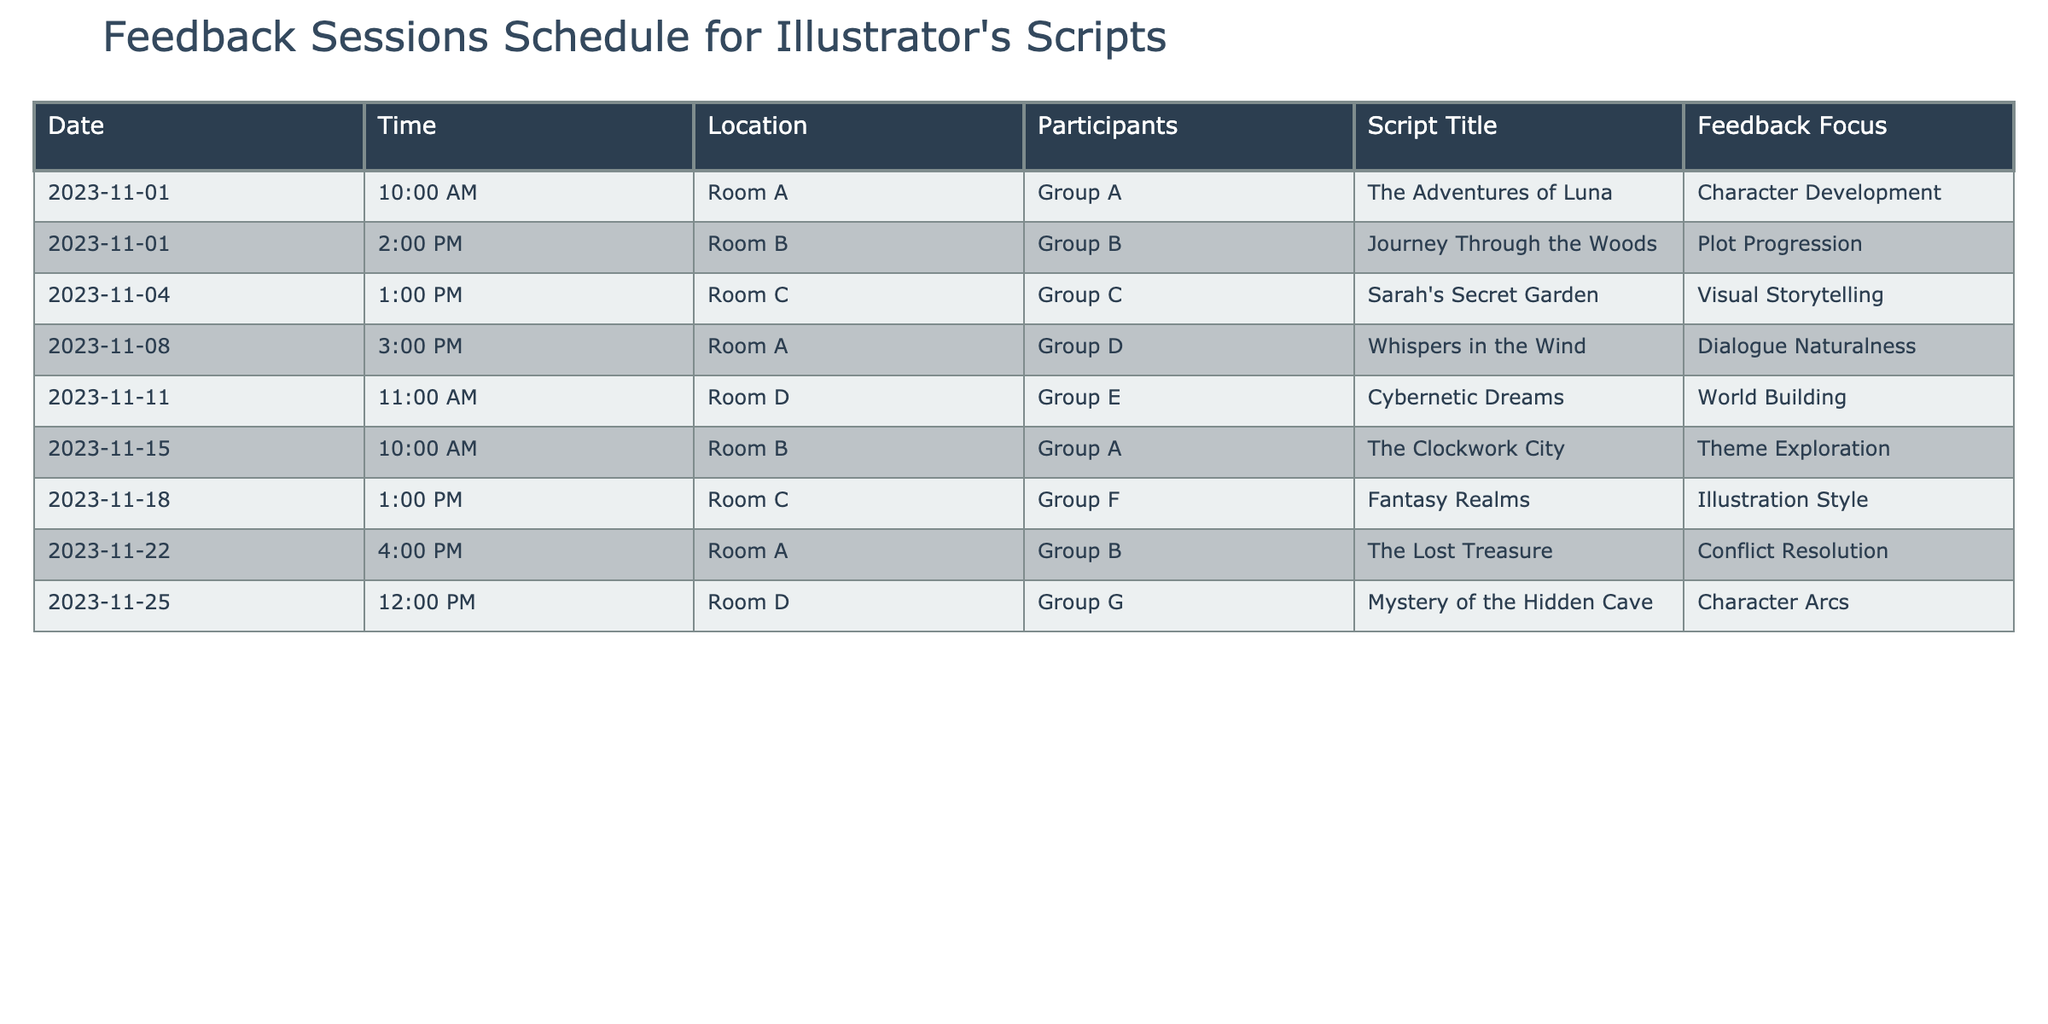What is the title of the script being discussed in the feedback session on November 8th? Referring to the table, look at the row corresponding to November 8th. The script title listed there is "Whispers in the Wind".
Answer: Whispers in the Wind Which group is receiving feedback on "The Clockwork City"? In the table, find the row that contains the script title "The Clockwork City". It lists Group A as the participant for that session.
Answer: Group A How many sessions focus on character development or character arcs? Look at the feedback focus column and filter for "Character Development" and "Character Arcs". There are two sessions: one on November 1st and another on November 25th.
Answer: 2 Is "Journey Through the Woods" scheduled before "Cybernetic Dreams"? Check the date column for both scripts. "Journey Through the Woods" is on November 1st and "Cybernetic Dreams" is on November 11th, meaning it is scheduled earlier.
Answer: Yes What is the time difference between the session focusing on visual storytelling and the session focusing on theme exploration? Review the time for the session on visual storytelling, which is at 1:00 PM on November 4th, and the session on theme exploration at 10:00 AM on November 15th. The time difference is 11 days and 9 hours.
Answer: 11 days and 9 hours How many unique group participants are involved across all sessions? By examining the participant column, list out each unique group: Groups A, B, C, D, E, F, and G. There are a total of 7 unique groups.
Answer: 7 What is the feedback focus of the last session in the schedule? Look at the last entry in the table. The session on November 25th focuses on "Character Arcs".
Answer: Character Arcs Are there more sessions focusing on illustration style or world building? Compare the counts from the feedback focus column; "Illustration Style" has one session (Group F), while "World Building" also has one session (Group E). Therefore, they are equal.
Answer: They are equal 